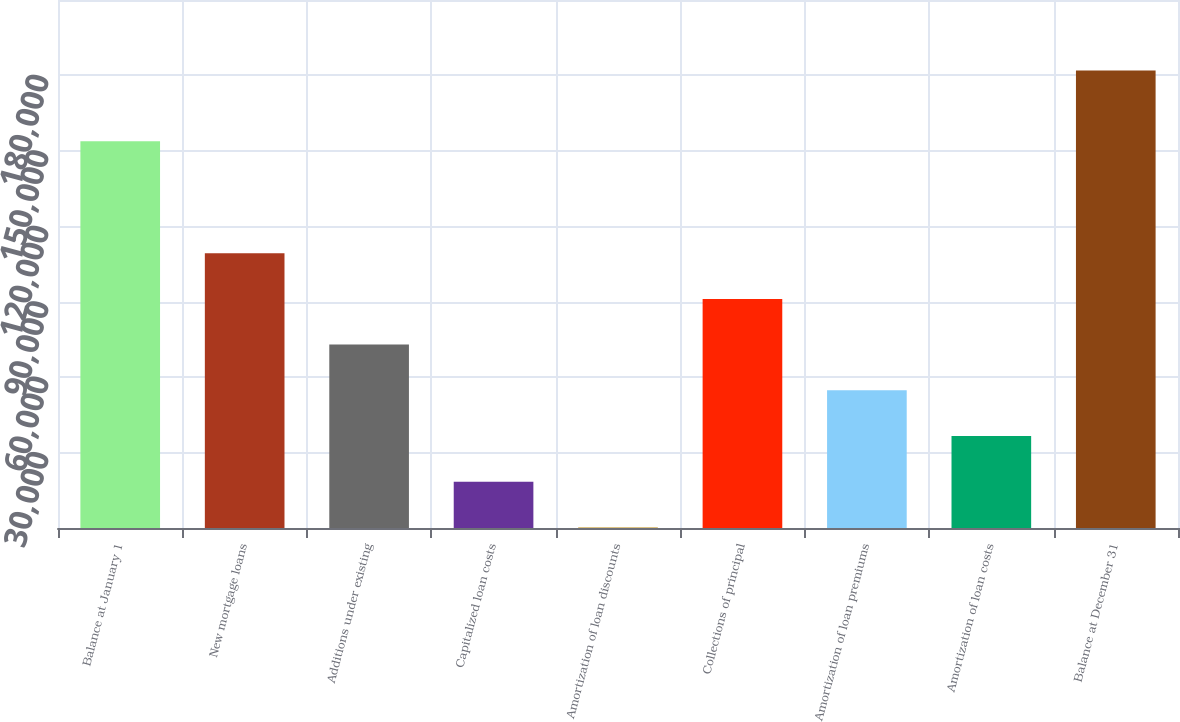<chart> <loc_0><loc_0><loc_500><loc_500><bar_chart><fcel>Balance at January 1<fcel>New mortgage loans<fcel>Additions under existing<fcel>Capitalized loan costs<fcel>Amortization of loan discounts<fcel>Collections of principal<fcel>Amortization of loan premiums<fcel>Amortization of loan costs<fcel>Balance at December 31<nl><fcel>153847<fcel>109294<fcel>72945<fcel>18421.5<fcel>247<fcel>91119.5<fcel>54770.5<fcel>36596<fcel>181992<nl></chart> 